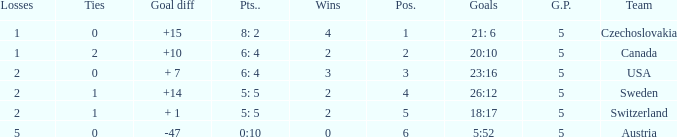What was the largest tie when the G.P was more than 5? None. 